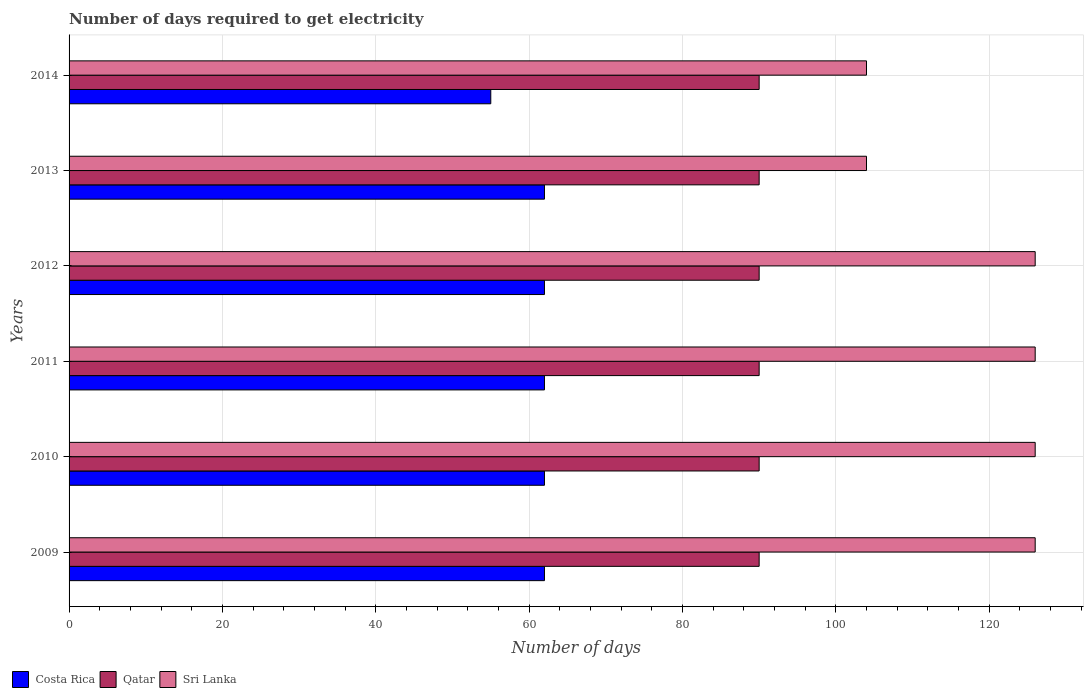How many groups of bars are there?
Ensure brevity in your answer.  6. How many bars are there on the 3rd tick from the bottom?
Your answer should be compact. 3. What is the number of days required to get electricity in in Costa Rica in 2009?
Ensure brevity in your answer.  62. Across all years, what is the maximum number of days required to get electricity in in Costa Rica?
Your answer should be compact. 62. Across all years, what is the minimum number of days required to get electricity in in Sri Lanka?
Your answer should be compact. 104. In which year was the number of days required to get electricity in in Qatar maximum?
Offer a terse response. 2009. What is the total number of days required to get electricity in in Costa Rica in the graph?
Offer a terse response. 365. What is the difference between the number of days required to get electricity in in Qatar in 2010 and that in 2011?
Offer a very short reply. 0. What is the difference between the number of days required to get electricity in in Qatar in 2010 and the number of days required to get electricity in in Costa Rica in 2011?
Provide a short and direct response. 28. What is the average number of days required to get electricity in in Costa Rica per year?
Your answer should be very brief. 60.83. In the year 2012, what is the difference between the number of days required to get electricity in in Costa Rica and number of days required to get electricity in in Qatar?
Give a very brief answer. -28. In how many years, is the number of days required to get electricity in in Costa Rica greater than 92 days?
Offer a very short reply. 0. What is the ratio of the number of days required to get electricity in in Sri Lanka in 2011 to that in 2014?
Give a very brief answer. 1.21. What is the difference between the highest and the second highest number of days required to get electricity in in Sri Lanka?
Make the answer very short. 0. What is the difference between the highest and the lowest number of days required to get electricity in in Costa Rica?
Give a very brief answer. 7. Is the sum of the number of days required to get electricity in in Sri Lanka in 2013 and 2014 greater than the maximum number of days required to get electricity in in Costa Rica across all years?
Your answer should be compact. Yes. What does the 1st bar from the top in 2013 represents?
Offer a terse response. Sri Lanka. What does the 2nd bar from the bottom in 2011 represents?
Provide a succinct answer. Qatar. How many bars are there?
Give a very brief answer. 18. How many legend labels are there?
Offer a terse response. 3. How are the legend labels stacked?
Your answer should be compact. Horizontal. What is the title of the graph?
Your answer should be compact. Number of days required to get electricity. What is the label or title of the X-axis?
Keep it short and to the point. Number of days. What is the Number of days in Costa Rica in 2009?
Offer a very short reply. 62. What is the Number of days in Sri Lanka in 2009?
Offer a terse response. 126. What is the Number of days of Sri Lanka in 2010?
Keep it short and to the point. 126. What is the Number of days in Costa Rica in 2011?
Your answer should be very brief. 62. What is the Number of days of Sri Lanka in 2011?
Give a very brief answer. 126. What is the Number of days of Costa Rica in 2012?
Offer a terse response. 62. What is the Number of days of Qatar in 2012?
Your answer should be compact. 90. What is the Number of days in Sri Lanka in 2012?
Provide a succinct answer. 126. What is the Number of days in Costa Rica in 2013?
Keep it short and to the point. 62. What is the Number of days of Sri Lanka in 2013?
Ensure brevity in your answer.  104. What is the Number of days in Sri Lanka in 2014?
Give a very brief answer. 104. Across all years, what is the maximum Number of days in Costa Rica?
Make the answer very short. 62. Across all years, what is the maximum Number of days in Qatar?
Your answer should be very brief. 90. Across all years, what is the maximum Number of days in Sri Lanka?
Keep it short and to the point. 126. Across all years, what is the minimum Number of days of Qatar?
Keep it short and to the point. 90. Across all years, what is the minimum Number of days of Sri Lanka?
Your response must be concise. 104. What is the total Number of days of Costa Rica in the graph?
Provide a succinct answer. 365. What is the total Number of days in Qatar in the graph?
Your response must be concise. 540. What is the total Number of days of Sri Lanka in the graph?
Make the answer very short. 712. What is the difference between the Number of days in Qatar in 2009 and that in 2011?
Give a very brief answer. 0. What is the difference between the Number of days of Costa Rica in 2009 and that in 2012?
Offer a very short reply. 0. What is the difference between the Number of days of Qatar in 2009 and that in 2012?
Keep it short and to the point. 0. What is the difference between the Number of days in Sri Lanka in 2009 and that in 2012?
Your answer should be compact. 0. What is the difference between the Number of days of Costa Rica in 2009 and that in 2013?
Your response must be concise. 0. What is the difference between the Number of days of Sri Lanka in 2009 and that in 2013?
Give a very brief answer. 22. What is the difference between the Number of days in Costa Rica in 2009 and that in 2014?
Ensure brevity in your answer.  7. What is the difference between the Number of days in Qatar in 2009 and that in 2014?
Give a very brief answer. 0. What is the difference between the Number of days in Sri Lanka in 2009 and that in 2014?
Your answer should be compact. 22. What is the difference between the Number of days of Sri Lanka in 2010 and that in 2011?
Make the answer very short. 0. What is the difference between the Number of days in Qatar in 2010 and that in 2012?
Ensure brevity in your answer.  0. What is the difference between the Number of days in Sri Lanka in 2010 and that in 2014?
Give a very brief answer. 22. What is the difference between the Number of days of Qatar in 2011 and that in 2012?
Your response must be concise. 0. What is the difference between the Number of days of Qatar in 2011 and that in 2013?
Offer a terse response. 0. What is the difference between the Number of days of Qatar in 2012 and that in 2013?
Your response must be concise. 0. What is the difference between the Number of days in Qatar in 2012 and that in 2014?
Offer a very short reply. 0. What is the difference between the Number of days of Sri Lanka in 2012 and that in 2014?
Your response must be concise. 22. What is the difference between the Number of days in Costa Rica in 2013 and that in 2014?
Provide a succinct answer. 7. What is the difference between the Number of days in Sri Lanka in 2013 and that in 2014?
Keep it short and to the point. 0. What is the difference between the Number of days in Costa Rica in 2009 and the Number of days in Sri Lanka in 2010?
Your answer should be very brief. -64. What is the difference between the Number of days in Qatar in 2009 and the Number of days in Sri Lanka in 2010?
Keep it short and to the point. -36. What is the difference between the Number of days of Costa Rica in 2009 and the Number of days of Sri Lanka in 2011?
Your answer should be compact. -64. What is the difference between the Number of days of Qatar in 2009 and the Number of days of Sri Lanka in 2011?
Give a very brief answer. -36. What is the difference between the Number of days of Costa Rica in 2009 and the Number of days of Sri Lanka in 2012?
Give a very brief answer. -64. What is the difference between the Number of days of Qatar in 2009 and the Number of days of Sri Lanka in 2012?
Provide a short and direct response. -36. What is the difference between the Number of days of Costa Rica in 2009 and the Number of days of Qatar in 2013?
Ensure brevity in your answer.  -28. What is the difference between the Number of days in Costa Rica in 2009 and the Number of days in Sri Lanka in 2013?
Provide a succinct answer. -42. What is the difference between the Number of days in Qatar in 2009 and the Number of days in Sri Lanka in 2013?
Provide a short and direct response. -14. What is the difference between the Number of days of Costa Rica in 2009 and the Number of days of Qatar in 2014?
Provide a short and direct response. -28. What is the difference between the Number of days of Costa Rica in 2009 and the Number of days of Sri Lanka in 2014?
Your response must be concise. -42. What is the difference between the Number of days of Qatar in 2009 and the Number of days of Sri Lanka in 2014?
Provide a short and direct response. -14. What is the difference between the Number of days in Costa Rica in 2010 and the Number of days in Sri Lanka in 2011?
Provide a short and direct response. -64. What is the difference between the Number of days in Qatar in 2010 and the Number of days in Sri Lanka in 2011?
Provide a succinct answer. -36. What is the difference between the Number of days in Costa Rica in 2010 and the Number of days in Qatar in 2012?
Provide a succinct answer. -28. What is the difference between the Number of days of Costa Rica in 2010 and the Number of days of Sri Lanka in 2012?
Offer a very short reply. -64. What is the difference between the Number of days of Qatar in 2010 and the Number of days of Sri Lanka in 2012?
Your response must be concise. -36. What is the difference between the Number of days in Costa Rica in 2010 and the Number of days in Sri Lanka in 2013?
Provide a succinct answer. -42. What is the difference between the Number of days in Qatar in 2010 and the Number of days in Sri Lanka in 2013?
Give a very brief answer. -14. What is the difference between the Number of days in Costa Rica in 2010 and the Number of days in Sri Lanka in 2014?
Give a very brief answer. -42. What is the difference between the Number of days in Qatar in 2010 and the Number of days in Sri Lanka in 2014?
Offer a very short reply. -14. What is the difference between the Number of days of Costa Rica in 2011 and the Number of days of Qatar in 2012?
Provide a short and direct response. -28. What is the difference between the Number of days in Costa Rica in 2011 and the Number of days in Sri Lanka in 2012?
Provide a short and direct response. -64. What is the difference between the Number of days of Qatar in 2011 and the Number of days of Sri Lanka in 2012?
Offer a very short reply. -36. What is the difference between the Number of days in Costa Rica in 2011 and the Number of days in Sri Lanka in 2013?
Make the answer very short. -42. What is the difference between the Number of days in Qatar in 2011 and the Number of days in Sri Lanka in 2013?
Keep it short and to the point. -14. What is the difference between the Number of days in Costa Rica in 2011 and the Number of days in Qatar in 2014?
Keep it short and to the point. -28. What is the difference between the Number of days in Costa Rica in 2011 and the Number of days in Sri Lanka in 2014?
Give a very brief answer. -42. What is the difference between the Number of days of Costa Rica in 2012 and the Number of days of Qatar in 2013?
Provide a succinct answer. -28. What is the difference between the Number of days of Costa Rica in 2012 and the Number of days of Sri Lanka in 2013?
Keep it short and to the point. -42. What is the difference between the Number of days of Costa Rica in 2012 and the Number of days of Qatar in 2014?
Your answer should be compact. -28. What is the difference between the Number of days of Costa Rica in 2012 and the Number of days of Sri Lanka in 2014?
Your answer should be compact. -42. What is the difference between the Number of days in Qatar in 2012 and the Number of days in Sri Lanka in 2014?
Provide a succinct answer. -14. What is the difference between the Number of days in Costa Rica in 2013 and the Number of days in Qatar in 2014?
Offer a very short reply. -28. What is the difference between the Number of days in Costa Rica in 2013 and the Number of days in Sri Lanka in 2014?
Offer a terse response. -42. What is the average Number of days in Costa Rica per year?
Offer a very short reply. 60.83. What is the average Number of days in Sri Lanka per year?
Provide a short and direct response. 118.67. In the year 2009, what is the difference between the Number of days in Costa Rica and Number of days in Sri Lanka?
Keep it short and to the point. -64. In the year 2009, what is the difference between the Number of days in Qatar and Number of days in Sri Lanka?
Offer a terse response. -36. In the year 2010, what is the difference between the Number of days of Costa Rica and Number of days of Qatar?
Provide a short and direct response. -28. In the year 2010, what is the difference between the Number of days in Costa Rica and Number of days in Sri Lanka?
Your response must be concise. -64. In the year 2010, what is the difference between the Number of days in Qatar and Number of days in Sri Lanka?
Give a very brief answer. -36. In the year 2011, what is the difference between the Number of days in Costa Rica and Number of days in Qatar?
Provide a succinct answer. -28. In the year 2011, what is the difference between the Number of days in Costa Rica and Number of days in Sri Lanka?
Offer a very short reply. -64. In the year 2011, what is the difference between the Number of days in Qatar and Number of days in Sri Lanka?
Ensure brevity in your answer.  -36. In the year 2012, what is the difference between the Number of days in Costa Rica and Number of days in Qatar?
Ensure brevity in your answer.  -28. In the year 2012, what is the difference between the Number of days in Costa Rica and Number of days in Sri Lanka?
Offer a very short reply. -64. In the year 2012, what is the difference between the Number of days of Qatar and Number of days of Sri Lanka?
Give a very brief answer. -36. In the year 2013, what is the difference between the Number of days in Costa Rica and Number of days in Sri Lanka?
Your answer should be very brief. -42. In the year 2013, what is the difference between the Number of days in Qatar and Number of days in Sri Lanka?
Offer a terse response. -14. In the year 2014, what is the difference between the Number of days in Costa Rica and Number of days in Qatar?
Provide a succinct answer. -35. In the year 2014, what is the difference between the Number of days of Costa Rica and Number of days of Sri Lanka?
Your answer should be compact. -49. In the year 2014, what is the difference between the Number of days of Qatar and Number of days of Sri Lanka?
Offer a terse response. -14. What is the ratio of the Number of days of Costa Rica in 2009 to that in 2010?
Keep it short and to the point. 1. What is the ratio of the Number of days in Qatar in 2009 to that in 2010?
Keep it short and to the point. 1. What is the ratio of the Number of days of Sri Lanka in 2009 to that in 2010?
Ensure brevity in your answer.  1. What is the ratio of the Number of days of Costa Rica in 2009 to that in 2011?
Your response must be concise. 1. What is the ratio of the Number of days in Qatar in 2009 to that in 2011?
Provide a short and direct response. 1. What is the ratio of the Number of days in Sri Lanka in 2009 to that in 2011?
Make the answer very short. 1. What is the ratio of the Number of days in Qatar in 2009 to that in 2012?
Provide a succinct answer. 1. What is the ratio of the Number of days in Qatar in 2009 to that in 2013?
Ensure brevity in your answer.  1. What is the ratio of the Number of days in Sri Lanka in 2009 to that in 2013?
Provide a short and direct response. 1.21. What is the ratio of the Number of days in Costa Rica in 2009 to that in 2014?
Keep it short and to the point. 1.13. What is the ratio of the Number of days in Sri Lanka in 2009 to that in 2014?
Your answer should be very brief. 1.21. What is the ratio of the Number of days of Costa Rica in 2010 to that in 2011?
Give a very brief answer. 1. What is the ratio of the Number of days in Qatar in 2010 to that in 2012?
Offer a very short reply. 1. What is the ratio of the Number of days of Costa Rica in 2010 to that in 2013?
Your answer should be compact. 1. What is the ratio of the Number of days of Sri Lanka in 2010 to that in 2013?
Your answer should be compact. 1.21. What is the ratio of the Number of days in Costa Rica in 2010 to that in 2014?
Ensure brevity in your answer.  1.13. What is the ratio of the Number of days of Sri Lanka in 2010 to that in 2014?
Your response must be concise. 1.21. What is the ratio of the Number of days of Qatar in 2011 to that in 2012?
Offer a terse response. 1. What is the ratio of the Number of days in Costa Rica in 2011 to that in 2013?
Offer a very short reply. 1. What is the ratio of the Number of days in Sri Lanka in 2011 to that in 2013?
Provide a short and direct response. 1.21. What is the ratio of the Number of days in Costa Rica in 2011 to that in 2014?
Ensure brevity in your answer.  1.13. What is the ratio of the Number of days in Qatar in 2011 to that in 2014?
Your answer should be compact. 1. What is the ratio of the Number of days of Sri Lanka in 2011 to that in 2014?
Keep it short and to the point. 1.21. What is the ratio of the Number of days in Costa Rica in 2012 to that in 2013?
Ensure brevity in your answer.  1. What is the ratio of the Number of days of Sri Lanka in 2012 to that in 2013?
Provide a succinct answer. 1.21. What is the ratio of the Number of days of Costa Rica in 2012 to that in 2014?
Your answer should be compact. 1.13. What is the ratio of the Number of days in Sri Lanka in 2012 to that in 2014?
Your response must be concise. 1.21. What is the ratio of the Number of days of Costa Rica in 2013 to that in 2014?
Offer a terse response. 1.13. What is the ratio of the Number of days of Qatar in 2013 to that in 2014?
Your answer should be very brief. 1. What is the ratio of the Number of days in Sri Lanka in 2013 to that in 2014?
Your answer should be compact. 1. What is the difference between the highest and the second highest Number of days of Costa Rica?
Your answer should be compact. 0. What is the difference between the highest and the second highest Number of days of Qatar?
Your answer should be very brief. 0. What is the difference between the highest and the lowest Number of days in Sri Lanka?
Make the answer very short. 22. 